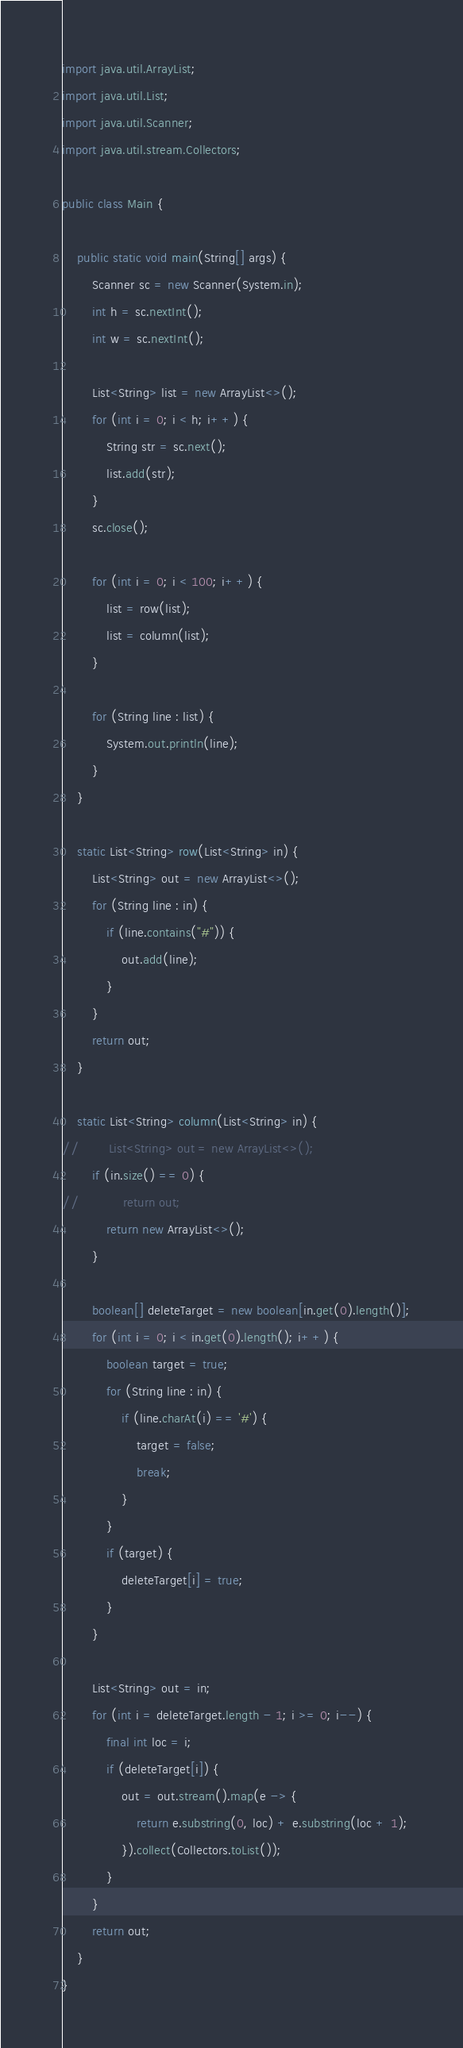<code> <loc_0><loc_0><loc_500><loc_500><_Java_>import java.util.ArrayList;
import java.util.List;
import java.util.Scanner;
import java.util.stream.Collectors;

public class Main {

    public static void main(String[] args) {
        Scanner sc = new Scanner(System.in);
        int h = sc.nextInt();
        int w = sc.nextInt();

        List<String> list = new ArrayList<>();
        for (int i = 0; i < h; i++) {
            String str = sc.next();
            list.add(str);
        }
        sc.close();

        for (int i = 0; i < 100; i++) {
            list = row(list);
            list = column(list);
        }

        for (String line : list) {
            System.out.println(line);
        }
    }

    static List<String> row(List<String> in) {
        List<String> out = new ArrayList<>();
        for (String line : in) {
            if (line.contains("#")) {
                out.add(line);
            }
        }
        return out;
    }

    static List<String> column(List<String> in) {
//        List<String> out = new ArrayList<>();
        if (in.size() == 0) {
//            return out;
            return new ArrayList<>();
        }

        boolean[] deleteTarget = new boolean[in.get(0).length()];
        for (int i = 0; i < in.get(0).length(); i++) {
            boolean target = true;
            for (String line : in) {
                if (line.charAt(i) == '#') {
                    target = false;
                    break;
                }
            }
            if (target) {
                deleteTarget[i] = true;
            }
        }

        List<String> out = in;
        for (int i = deleteTarget.length - 1; i >= 0; i--) {
            final int loc = i;
            if (deleteTarget[i]) {
                out = out.stream().map(e -> {
                    return e.substring(0, loc) + e.substring(loc + 1);
                }).collect(Collectors.toList());
            }
        }
        return out;
    }
}
</code> 